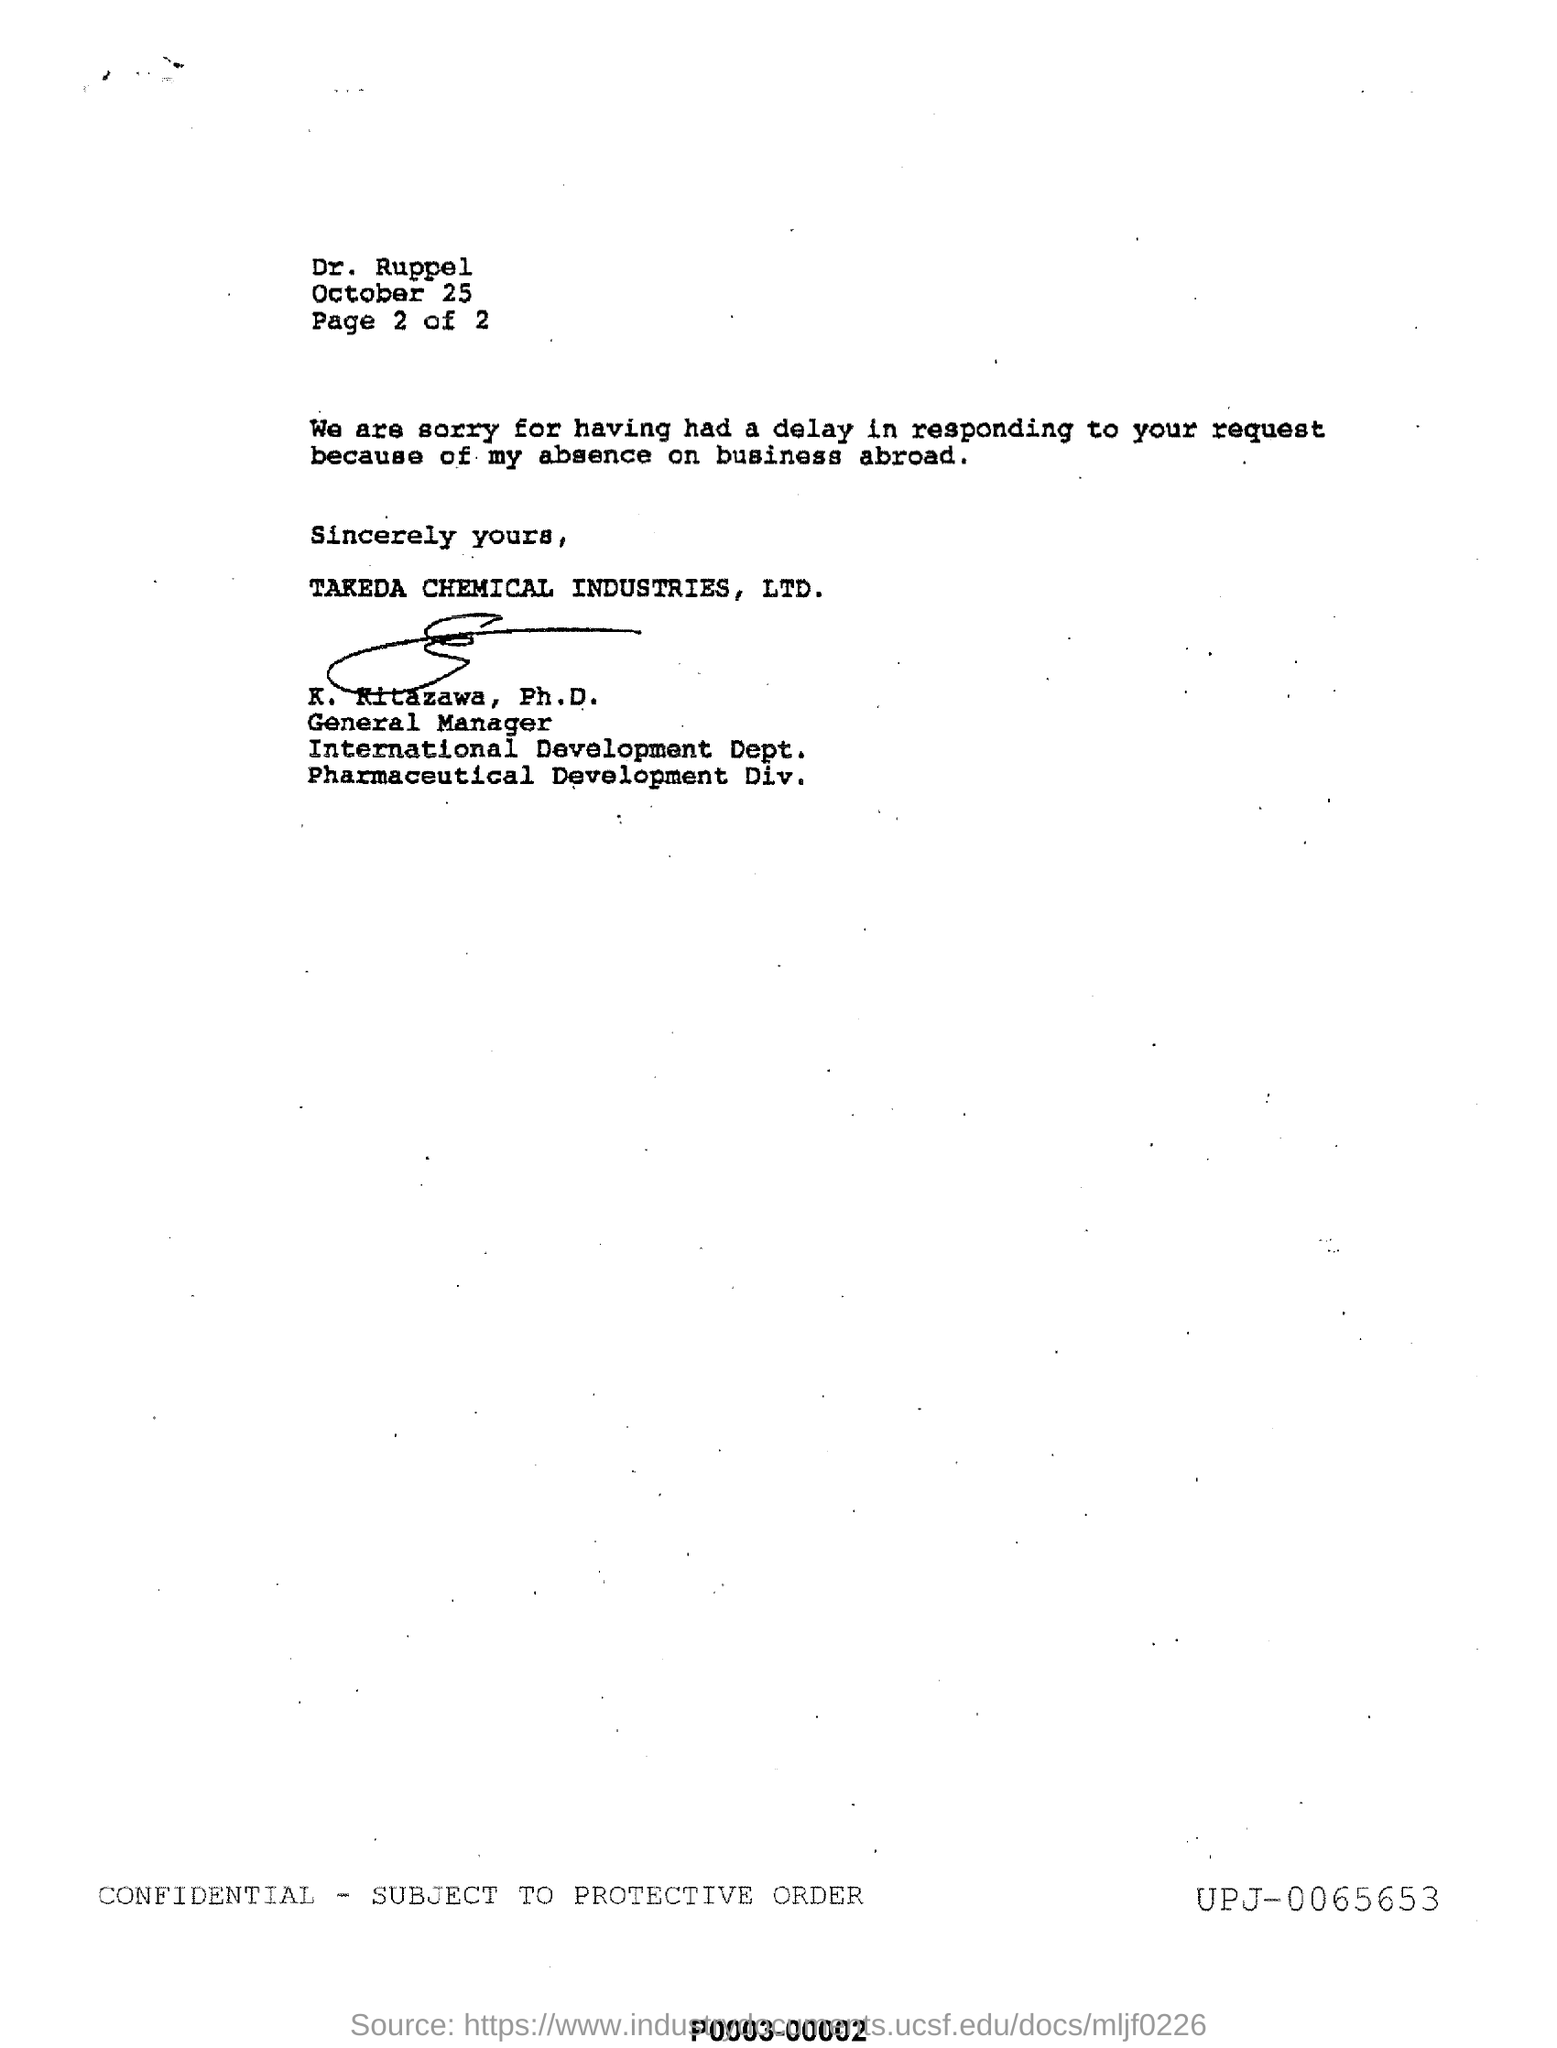Who is the general manager of International development Dept. of Takeda Chemical Industires, Ltd.?
Give a very brief answer. K. Kitazawa, Ph. D. What is the name of the industry ?
Offer a terse response. TAKEDA CHEMICAL INDUSTRIES , LTD . How many pages are there in total?
Offer a terse response. Page 2 of 2. What is the month and date mentioned in this letter, at the top ?
Offer a very short reply. October 25. 